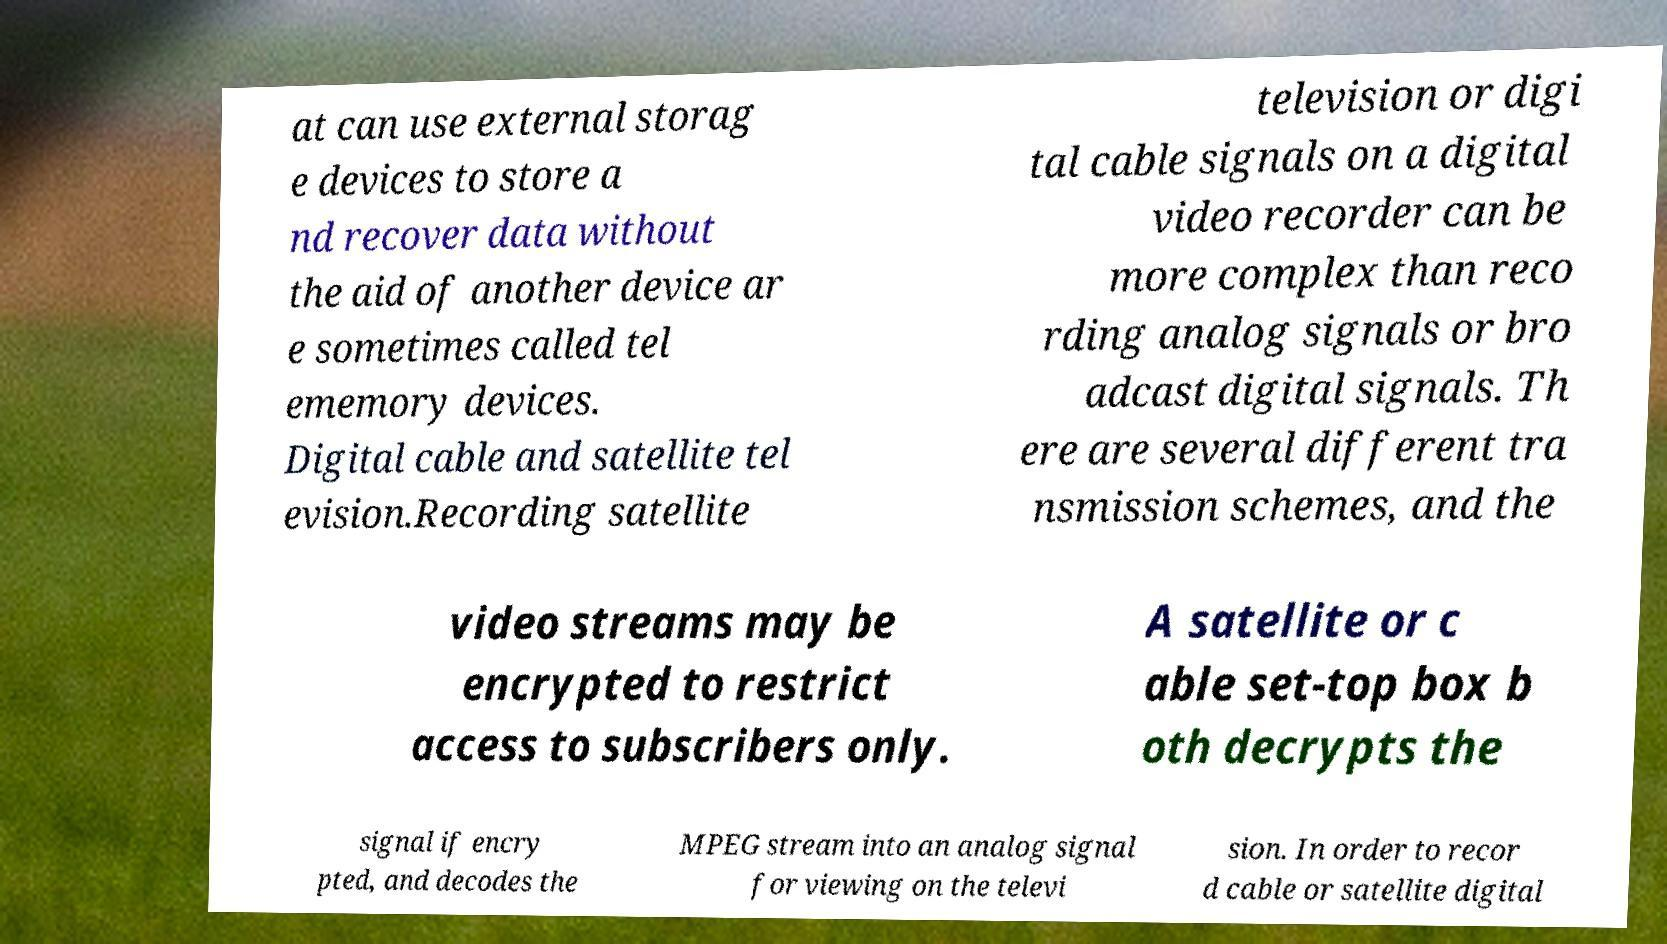Please identify and transcribe the text found in this image. at can use external storag e devices to store a nd recover data without the aid of another device ar e sometimes called tel ememory devices. Digital cable and satellite tel evision.Recording satellite television or digi tal cable signals on a digital video recorder can be more complex than reco rding analog signals or bro adcast digital signals. Th ere are several different tra nsmission schemes, and the video streams may be encrypted to restrict access to subscribers only. A satellite or c able set-top box b oth decrypts the signal if encry pted, and decodes the MPEG stream into an analog signal for viewing on the televi sion. In order to recor d cable or satellite digital 